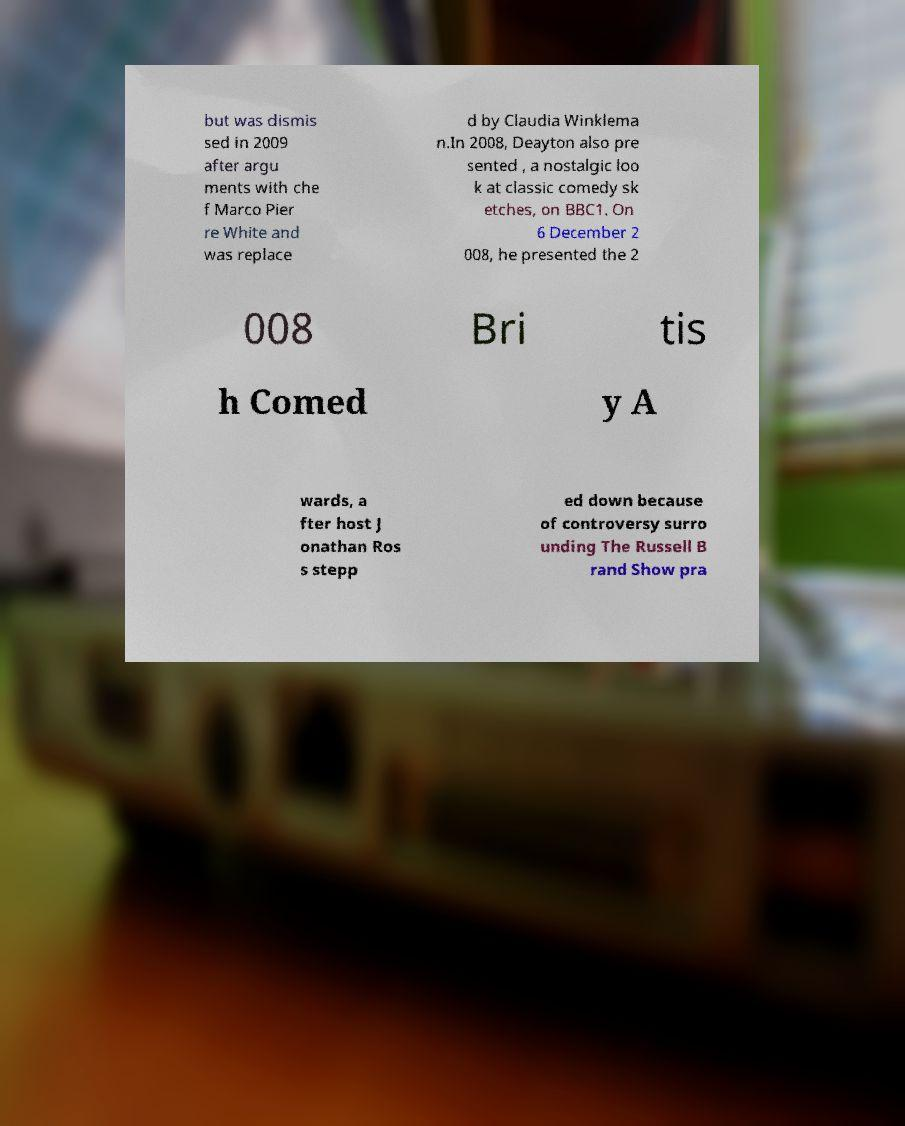Please read and relay the text visible in this image. What does it say? but was dismis sed in 2009 after argu ments with che f Marco Pier re White and was replace d by Claudia Winklema n.In 2008, Deayton also pre sented , a nostalgic loo k at classic comedy sk etches, on BBC1. On 6 December 2 008, he presented the 2 008 Bri tis h Comed y A wards, a fter host J onathan Ros s stepp ed down because of controversy surro unding The Russell B rand Show pra 